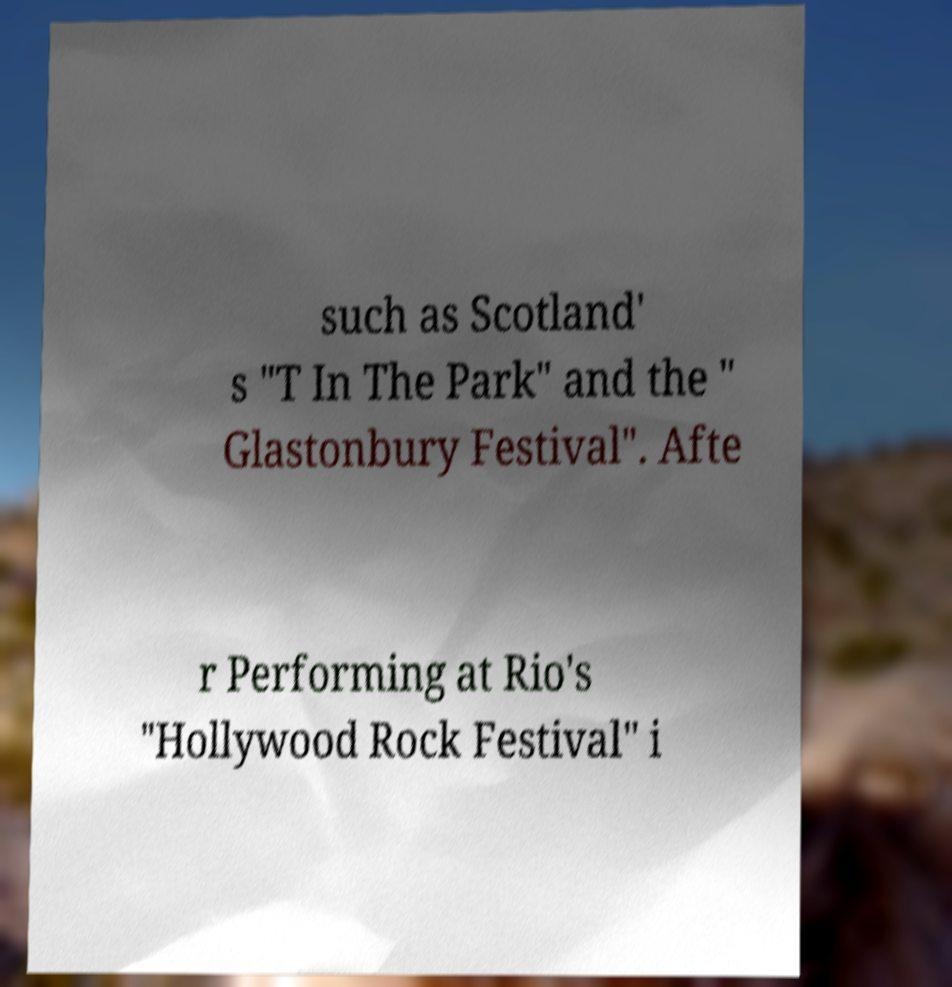Can you accurately transcribe the text from the provided image for me? such as Scotland' s "T In The Park" and the " Glastonbury Festival". Afte r Performing at Rio's "Hollywood Rock Festival" i 